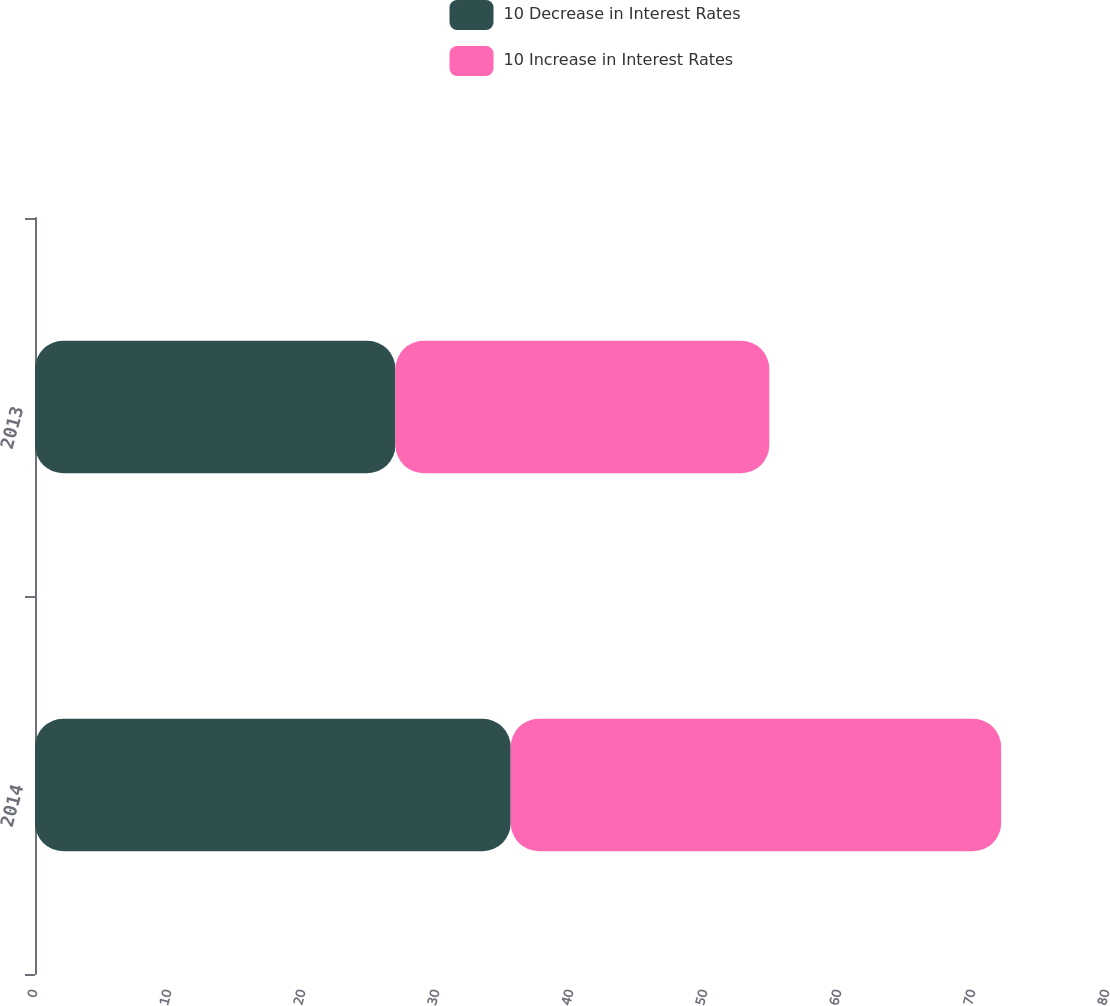<chart> <loc_0><loc_0><loc_500><loc_500><stacked_bar_chart><ecel><fcel>2014<fcel>2013<nl><fcel>10 Decrease in Interest Rates<fcel>35.5<fcel>26.9<nl><fcel>10 Increase in Interest Rates<fcel>36.6<fcel>27.9<nl></chart> 